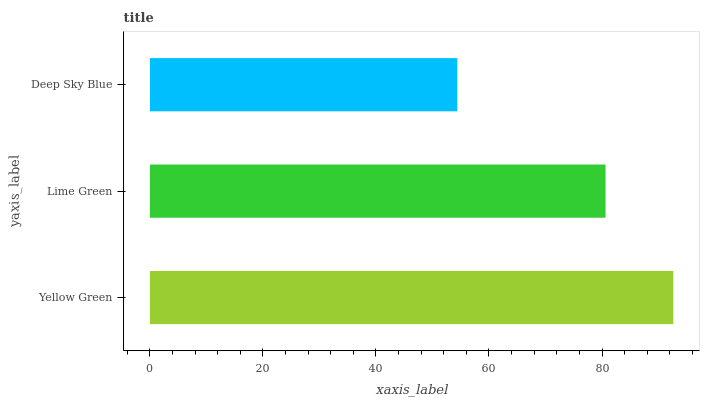Is Deep Sky Blue the minimum?
Answer yes or no. Yes. Is Yellow Green the maximum?
Answer yes or no. Yes. Is Lime Green the minimum?
Answer yes or no. No. Is Lime Green the maximum?
Answer yes or no. No. Is Yellow Green greater than Lime Green?
Answer yes or no. Yes. Is Lime Green less than Yellow Green?
Answer yes or no. Yes. Is Lime Green greater than Yellow Green?
Answer yes or no. No. Is Yellow Green less than Lime Green?
Answer yes or no. No. Is Lime Green the high median?
Answer yes or no. Yes. Is Lime Green the low median?
Answer yes or no. Yes. Is Deep Sky Blue the high median?
Answer yes or no. No. Is Deep Sky Blue the low median?
Answer yes or no. No. 